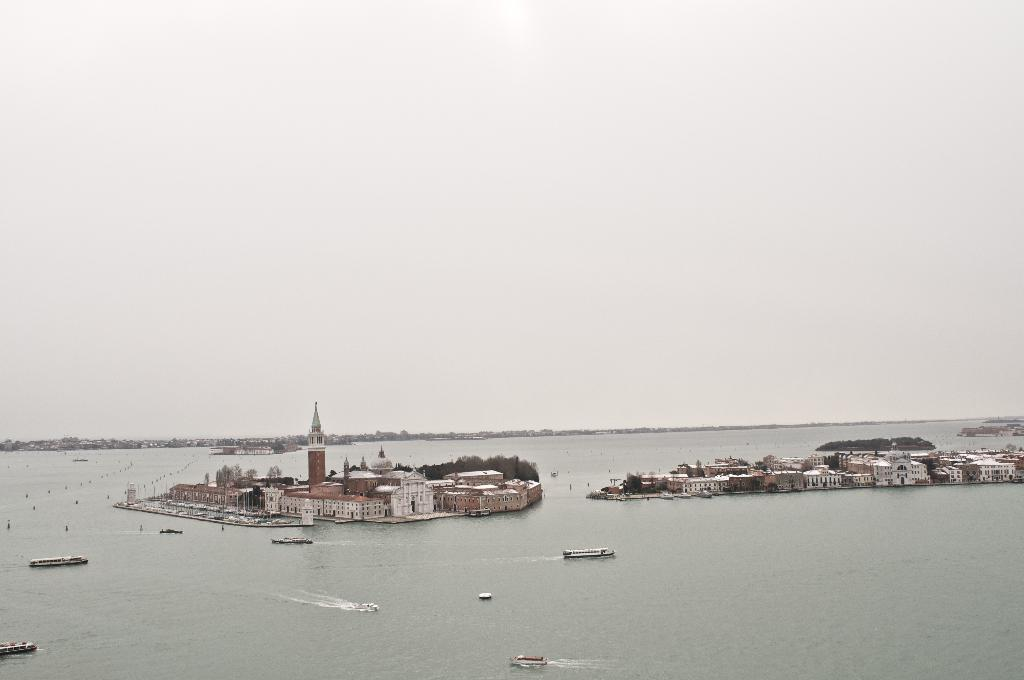What is in the water in the image? There are boats in the water in the image. What can be seen near the boats? There are buildings and trees near the boats. How many buildings are visible in the image? There are more buildings visible in the image. What is visible in the sky in the image? The sky is visible in the image. What type of plants can be seen growing on the boats in the image? There are no plants visible on the boats in the image. 